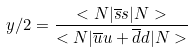<formula> <loc_0><loc_0><loc_500><loc_500>y / 2 = \frac { < N | \overline { s } s | N > } { < N | \overline { u } u + \overline { d } d | N > }</formula> 